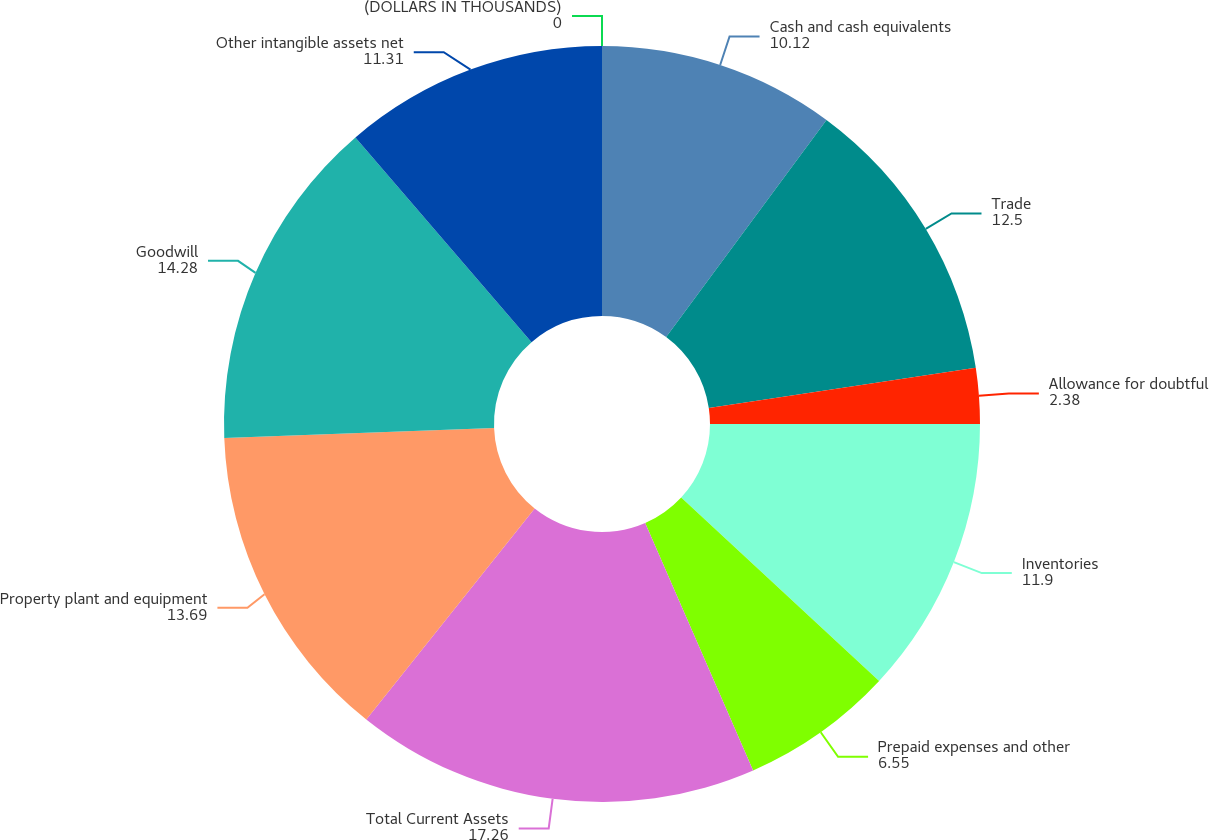Convert chart. <chart><loc_0><loc_0><loc_500><loc_500><pie_chart><fcel>(DOLLARS IN THOUSANDS)<fcel>Cash and cash equivalents<fcel>Trade<fcel>Allowance for doubtful<fcel>Inventories<fcel>Prepaid expenses and other<fcel>Total Current Assets<fcel>Property plant and equipment<fcel>Goodwill<fcel>Other intangible assets net<nl><fcel>0.0%<fcel>10.12%<fcel>12.5%<fcel>2.38%<fcel>11.9%<fcel>6.55%<fcel>17.26%<fcel>13.69%<fcel>14.28%<fcel>11.31%<nl></chart> 